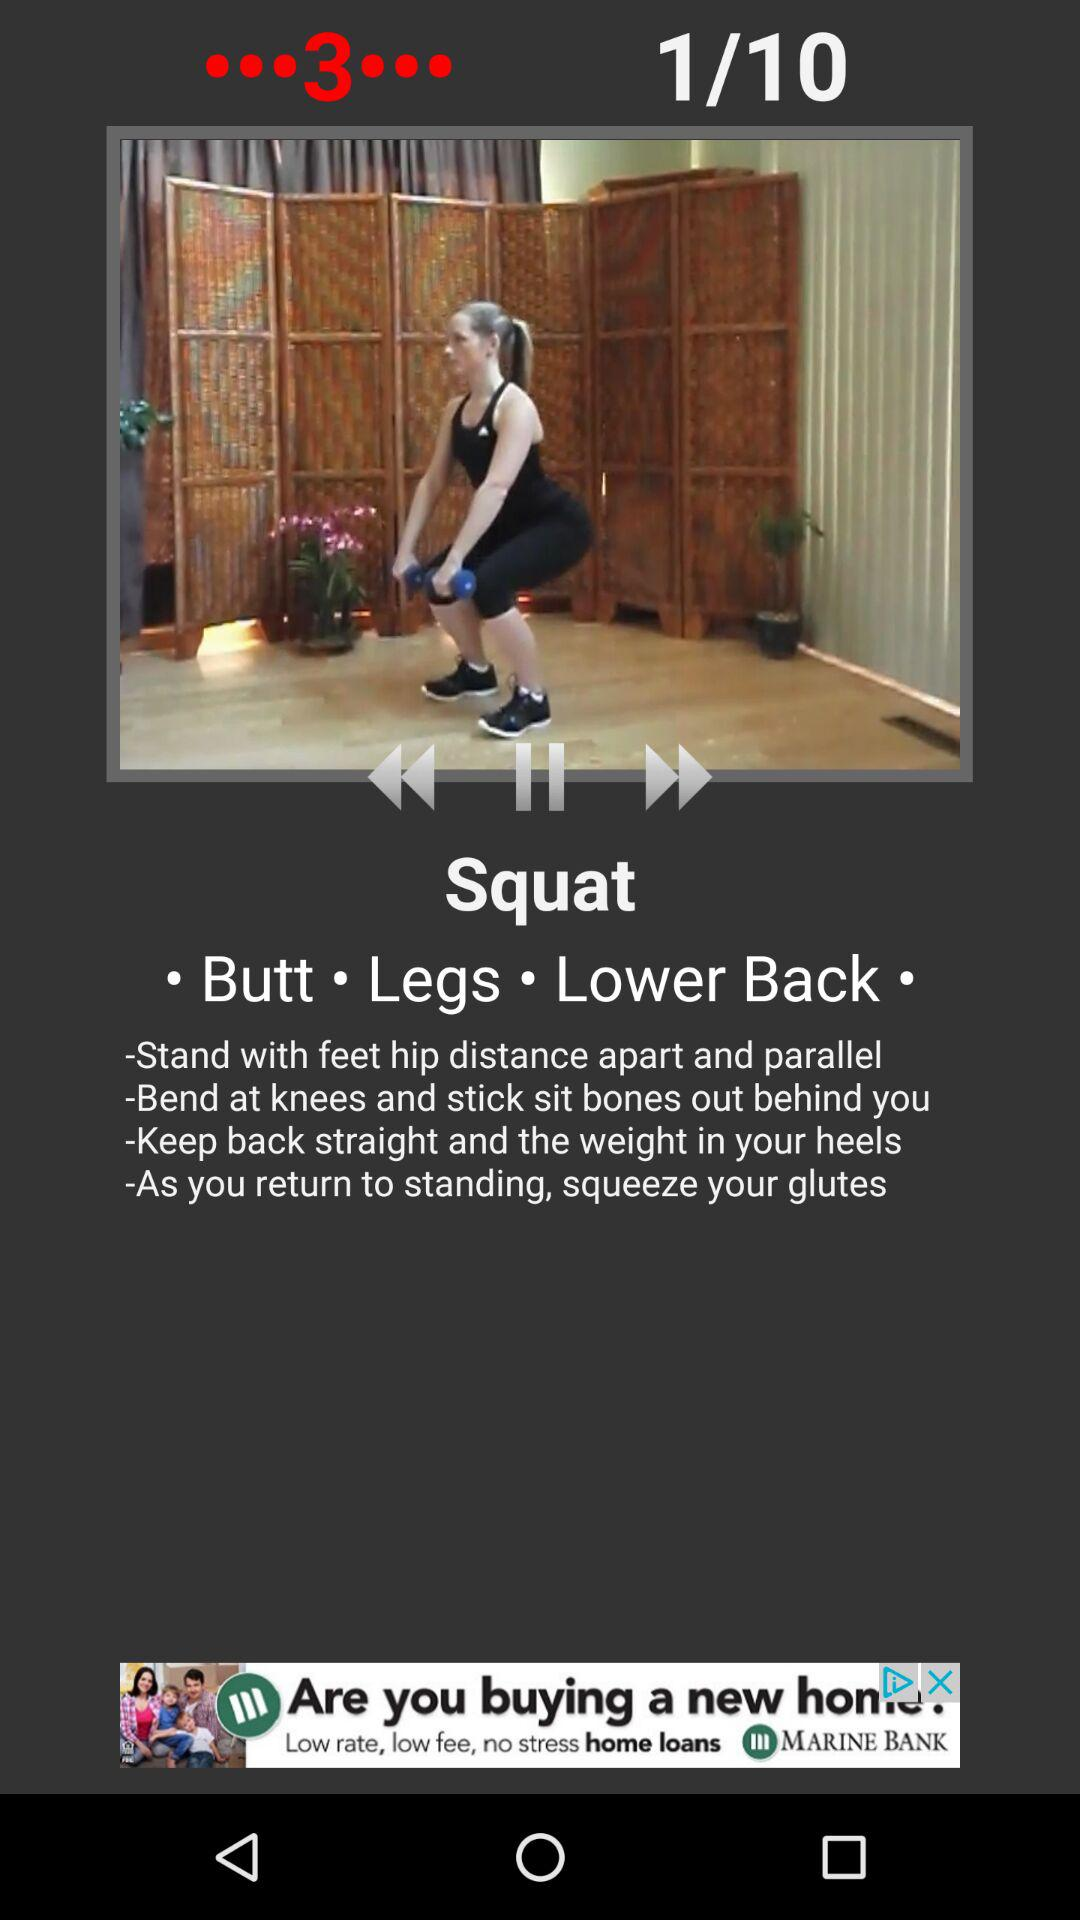How many steps are there in the squat exercise?
Answer the question using a single word or phrase. 4 